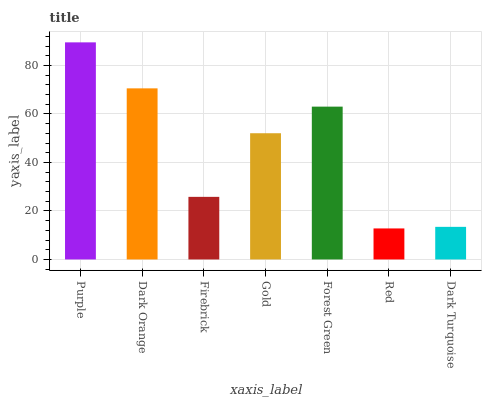Is Red the minimum?
Answer yes or no. Yes. Is Purple the maximum?
Answer yes or no. Yes. Is Dark Orange the minimum?
Answer yes or no. No. Is Dark Orange the maximum?
Answer yes or no. No. Is Purple greater than Dark Orange?
Answer yes or no. Yes. Is Dark Orange less than Purple?
Answer yes or no. Yes. Is Dark Orange greater than Purple?
Answer yes or no. No. Is Purple less than Dark Orange?
Answer yes or no. No. Is Gold the high median?
Answer yes or no. Yes. Is Gold the low median?
Answer yes or no. Yes. Is Purple the high median?
Answer yes or no. No. Is Firebrick the low median?
Answer yes or no. No. 